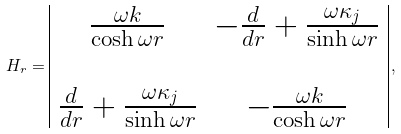Convert formula to latex. <formula><loc_0><loc_0><loc_500><loc_500>H _ { r } = \begin{array} { | c c | } \frac { \omega k } { \cosh \omega r } & - \frac { d } { d r } + \frac { \omega \kappa _ { j } } { \sinh \omega r } \\ & \\ \frac { d } { d r } + \frac { \omega \kappa _ { j } } { \sinh \omega r } & - \frac { \omega k } { \cosh \omega r } \end{array} \, ,</formula> 